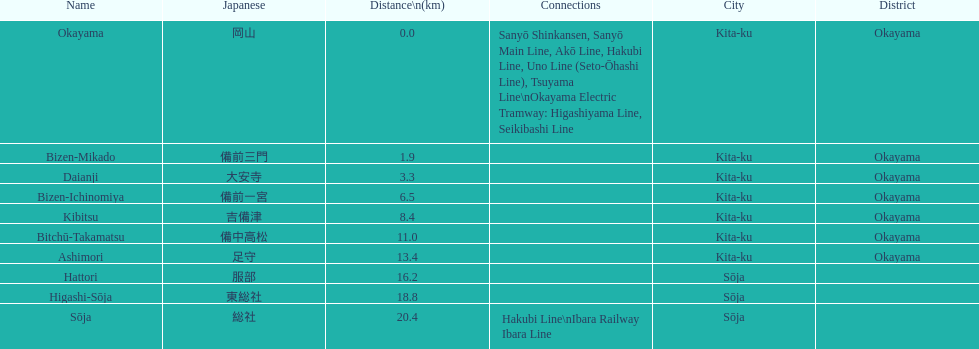How many station are located in kita-ku, okayama? 7. 